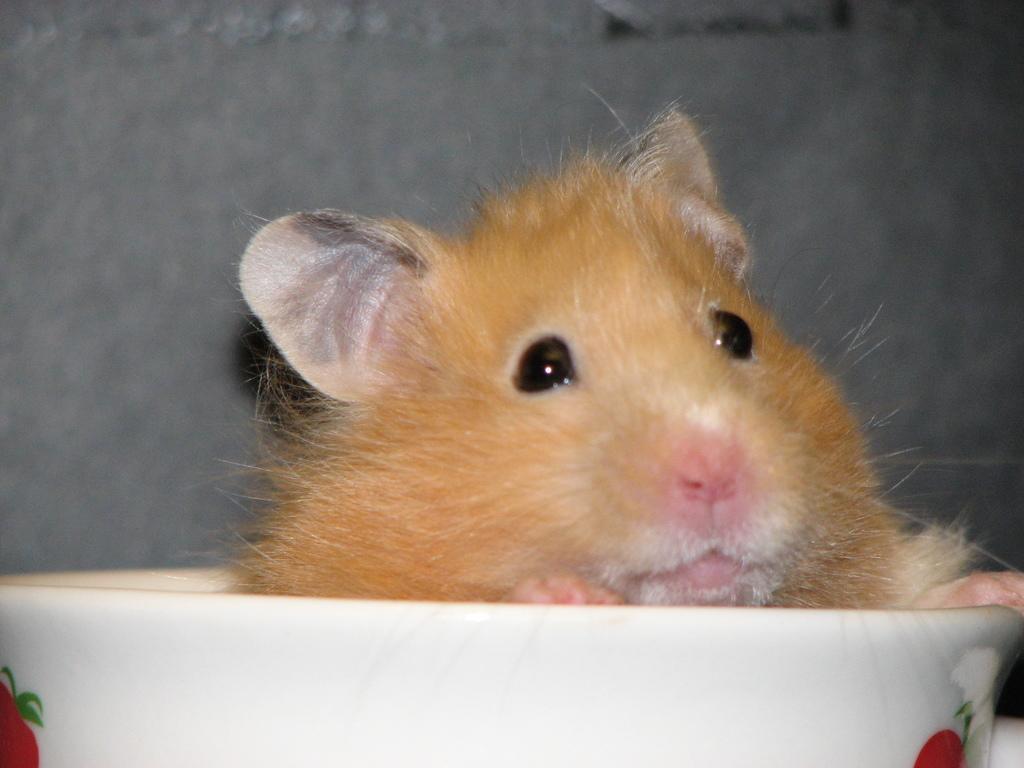Describe this image in one or two sentences. This is a picture of animal in the bowl in the foreground and the color of the bowl is white color with some red design. And there is wall in the background. 